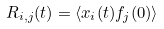Convert formula to latex. <formula><loc_0><loc_0><loc_500><loc_500>R _ { i , j } ( t ) = \langle x _ { i } ( t ) f _ { j } ( 0 ) \rangle</formula> 